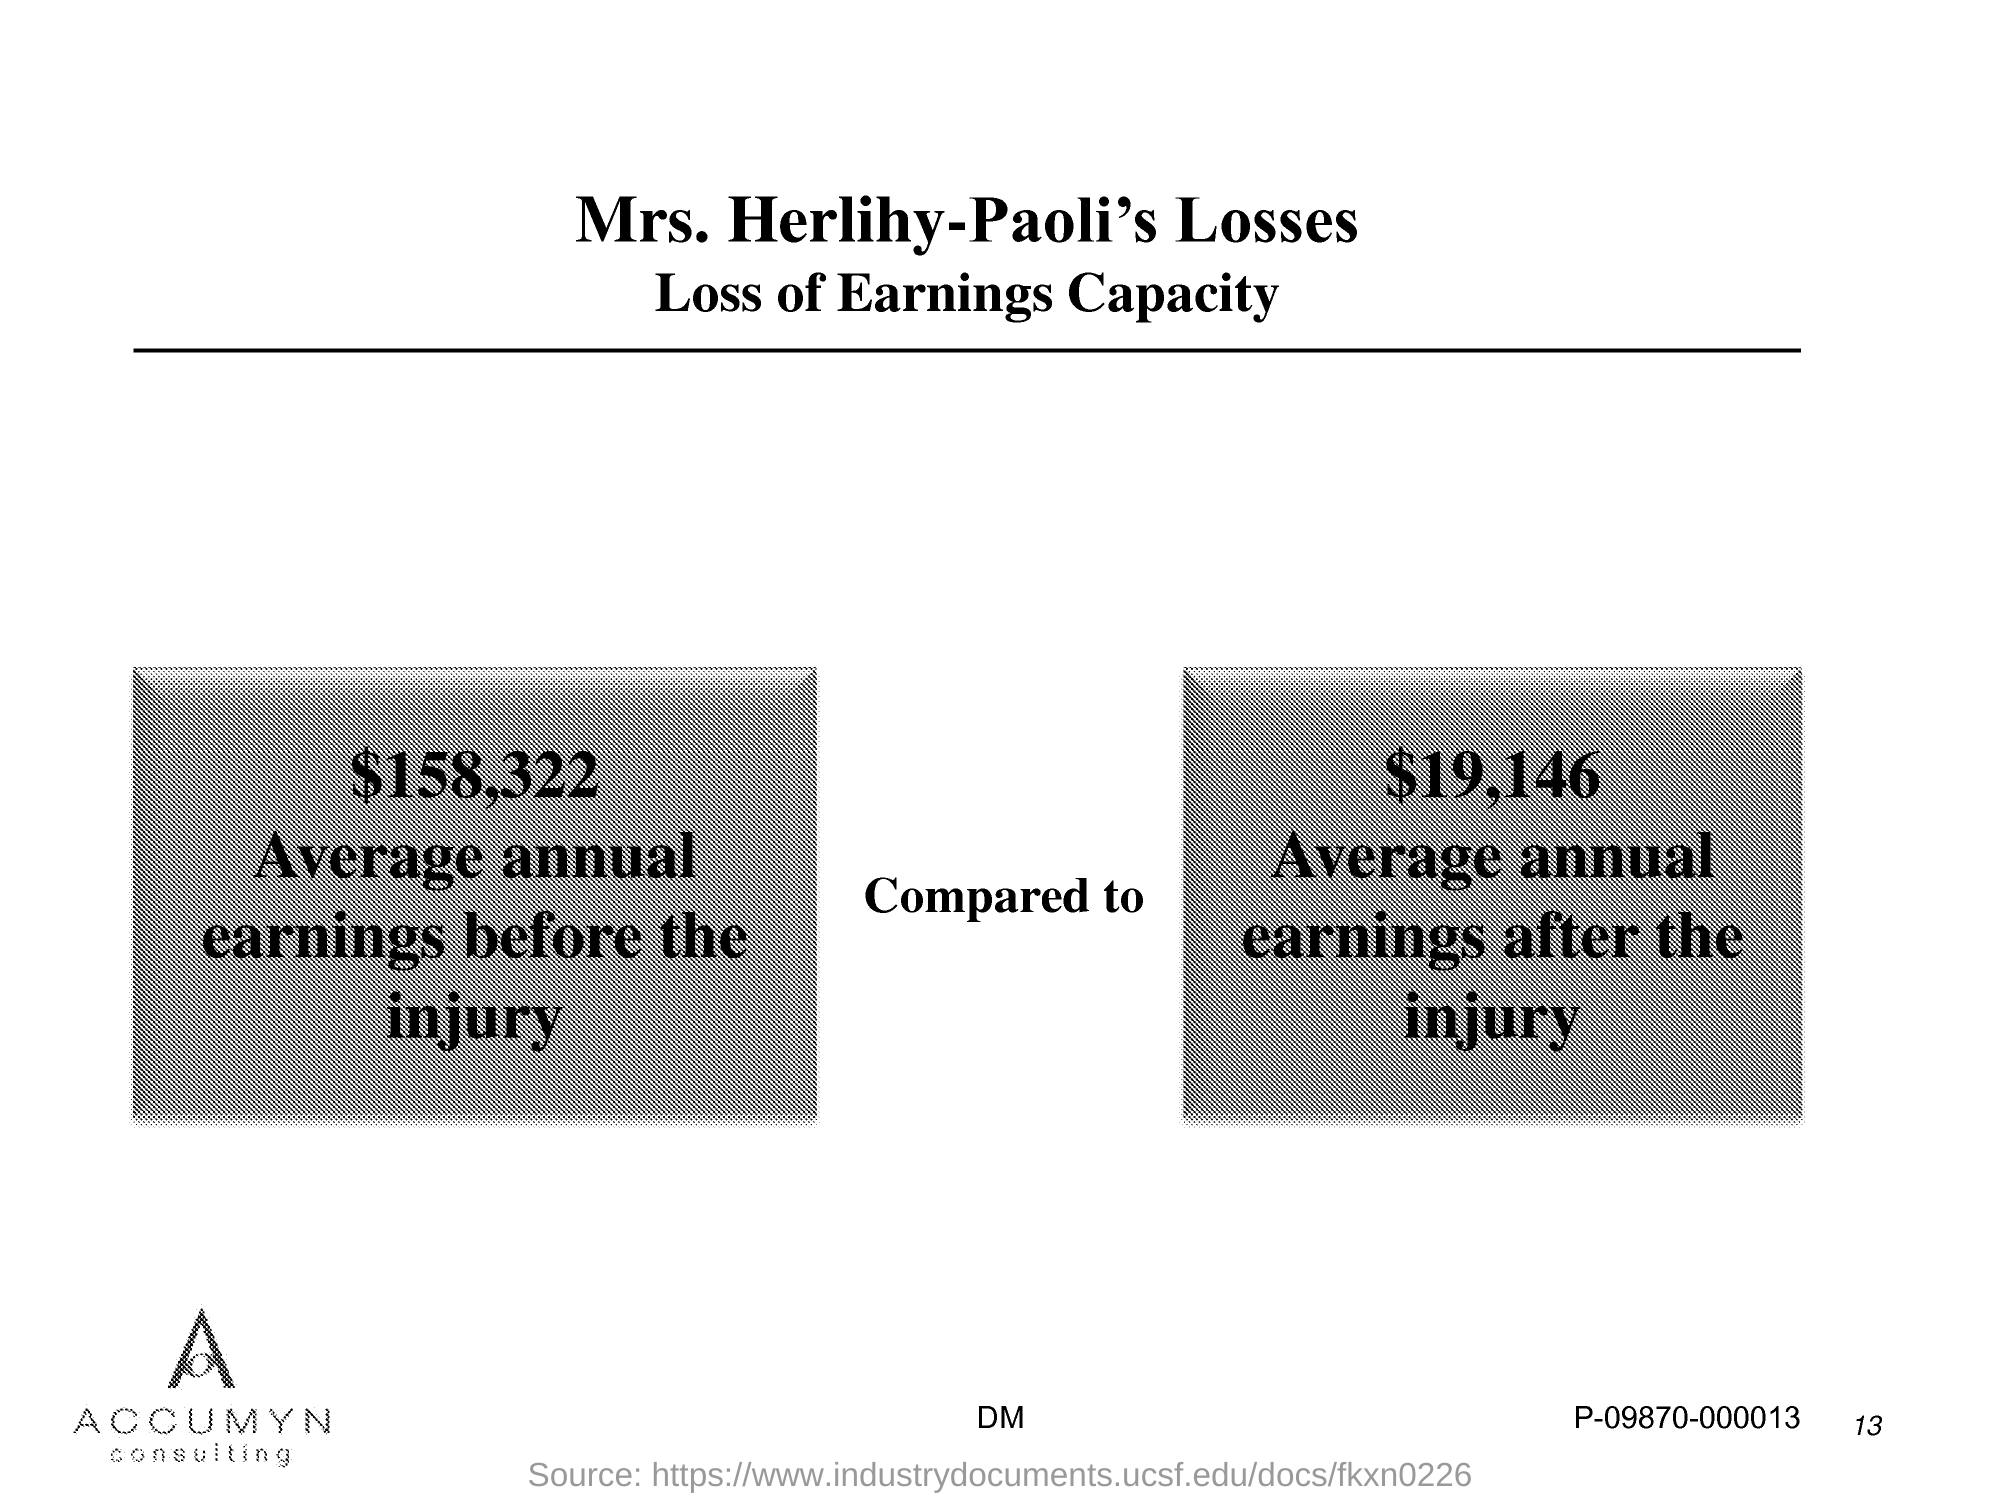What is the page no mentioned in this document?
Provide a short and direct response. 13. What is the average annual earnings before the injury?
Your response must be concise. $158,322. What is the average annual earnings after the injury?
Offer a very short reply. $19,146. 